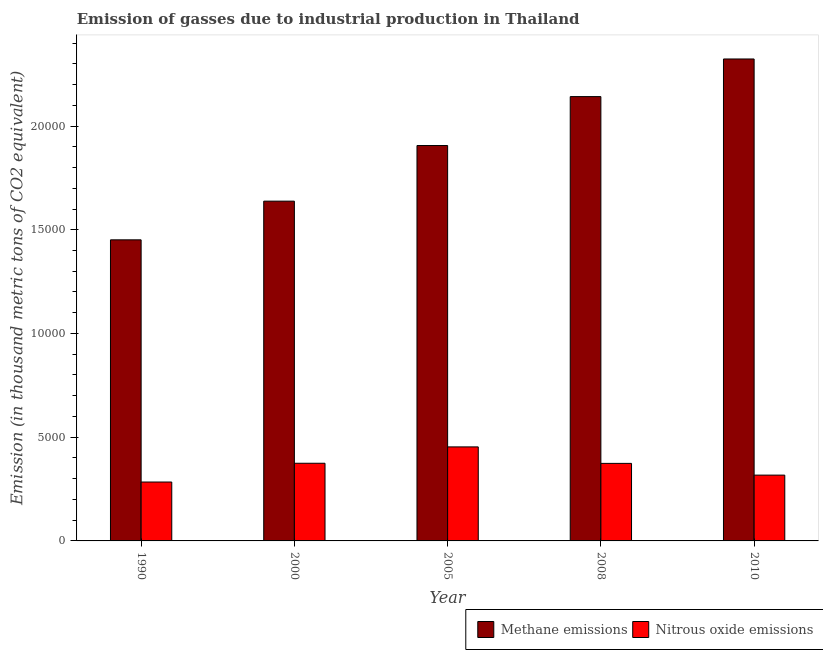How many different coloured bars are there?
Your answer should be compact. 2. How many groups of bars are there?
Your answer should be compact. 5. How many bars are there on the 4th tick from the left?
Offer a very short reply. 2. How many bars are there on the 4th tick from the right?
Offer a terse response. 2. What is the label of the 1st group of bars from the left?
Give a very brief answer. 1990. In how many cases, is the number of bars for a given year not equal to the number of legend labels?
Your answer should be very brief. 0. What is the amount of nitrous oxide emissions in 1990?
Ensure brevity in your answer.  2838.9. Across all years, what is the maximum amount of methane emissions?
Provide a short and direct response. 2.32e+04. Across all years, what is the minimum amount of nitrous oxide emissions?
Keep it short and to the point. 2838.9. In which year was the amount of nitrous oxide emissions maximum?
Your response must be concise. 2005. In which year was the amount of nitrous oxide emissions minimum?
Offer a terse response. 1990. What is the total amount of nitrous oxide emissions in the graph?
Offer a terse response. 1.80e+04. What is the difference between the amount of methane emissions in 2000 and that in 2010?
Make the answer very short. -6853.2. What is the difference between the amount of nitrous oxide emissions in 1990 and the amount of methane emissions in 2010?
Make the answer very short. -333.5. What is the average amount of methane emissions per year?
Keep it short and to the point. 1.89e+04. What is the ratio of the amount of methane emissions in 2000 to that in 2005?
Ensure brevity in your answer.  0.86. Is the amount of nitrous oxide emissions in 1990 less than that in 2005?
Your answer should be very brief. Yes. Is the difference between the amount of methane emissions in 2000 and 2010 greater than the difference between the amount of nitrous oxide emissions in 2000 and 2010?
Your answer should be very brief. No. What is the difference between the highest and the second highest amount of nitrous oxide emissions?
Provide a short and direct response. 788.7. What is the difference between the highest and the lowest amount of nitrous oxide emissions?
Your response must be concise. 1693.5. In how many years, is the amount of nitrous oxide emissions greater than the average amount of nitrous oxide emissions taken over all years?
Provide a succinct answer. 3. Is the sum of the amount of methane emissions in 2008 and 2010 greater than the maximum amount of nitrous oxide emissions across all years?
Ensure brevity in your answer.  Yes. What does the 2nd bar from the left in 2005 represents?
Keep it short and to the point. Nitrous oxide emissions. What does the 2nd bar from the right in 2008 represents?
Your response must be concise. Methane emissions. How many bars are there?
Make the answer very short. 10. Are all the bars in the graph horizontal?
Your answer should be very brief. No. How many years are there in the graph?
Offer a terse response. 5. What is the difference between two consecutive major ticks on the Y-axis?
Give a very brief answer. 5000. Does the graph contain any zero values?
Give a very brief answer. No. Where does the legend appear in the graph?
Give a very brief answer. Bottom right. How are the legend labels stacked?
Ensure brevity in your answer.  Horizontal. What is the title of the graph?
Your response must be concise. Emission of gasses due to industrial production in Thailand. What is the label or title of the Y-axis?
Give a very brief answer. Emission (in thousand metric tons of CO2 equivalent). What is the Emission (in thousand metric tons of CO2 equivalent) in Methane emissions in 1990?
Your answer should be very brief. 1.45e+04. What is the Emission (in thousand metric tons of CO2 equivalent) of Nitrous oxide emissions in 1990?
Your response must be concise. 2838.9. What is the Emission (in thousand metric tons of CO2 equivalent) of Methane emissions in 2000?
Your answer should be very brief. 1.64e+04. What is the Emission (in thousand metric tons of CO2 equivalent) of Nitrous oxide emissions in 2000?
Offer a terse response. 3743.7. What is the Emission (in thousand metric tons of CO2 equivalent) of Methane emissions in 2005?
Your answer should be very brief. 1.91e+04. What is the Emission (in thousand metric tons of CO2 equivalent) in Nitrous oxide emissions in 2005?
Ensure brevity in your answer.  4532.4. What is the Emission (in thousand metric tons of CO2 equivalent) in Methane emissions in 2008?
Your answer should be compact. 2.14e+04. What is the Emission (in thousand metric tons of CO2 equivalent) of Nitrous oxide emissions in 2008?
Make the answer very short. 3737.9. What is the Emission (in thousand metric tons of CO2 equivalent) of Methane emissions in 2010?
Your answer should be compact. 2.32e+04. What is the Emission (in thousand metric tons of CO2 equivalent) in Nitrous oxide emissions in 2010?
Your answer should be very brief. 3172.4. Across all years, what is the maximum Emission (in thousand metric tons of CO2 equivalent) in Methane emissions?
Provide a short and direct response. 2.32e+04. Across all years, what is the maximum Emission (in thousand metric tons of CO2 equivalent) in Nitrous oxide emissions?
Offer a terse response. 4532.4. Across all years, what is the minimum Emission (in thousand metric tons of CO2 equivalent) of Methane emissions?
Your answer should be very brief. 1.45e+04. Across all years, what is the minimum Emission (in thousand metric tons of CO2 equivalent) in Nitrous oxide emissions?
Your answer should be compact. 2838.9. What is the total Emission (in thousand metric tons of CO2 equivalent) of Methane emissions in the graph?
Your answer should be compact. 9.46e+04. What is the total Emission (in thousand metric tons of CO2 equivalent) of Nitrous oxide emissions in the graph?
Provide a succinct answer. 1.80e+04. What is the difference between the Emission (in thousand metric tons of CO2 equivalent) of Methane emissions in 1990 and that in 2000?
Your answer should be very brief. -1865.4. What is the difference between the Emission (in thousand metric tons of CO2 equivalent) of Nitrous oxide emissions in 1990 and that in 2000?
Provide a succinct answer. -904.8. What is the difference between the Emission (in thousand metric tons of CO2 equivalent) in Methane emissions in 1990 and that in 2005?
Give a very brief answer. -4546.4. What is the difference between the Emission (in thousand metric tons of CO2 equivalent) in Nitrous oxide emissions in 1990 and that in 2005?
Offer a terse response. -1693.5. What is the difference between the Emission (in thousand metric tons of CO2 equivalent) of Methane emissions in 1990 and that in 2008?
Make the answer very short. -6904.8. What is the difference between the Emission (in thousand metric tons of CO2 equivalent) of Nitrous oxide emissions in 1990 and that in 2008?
Give a very brief answer. -899. What is the difference between the Emission (in thousand metric tons of CO2 equivalent) in Methane emissions in 1990 and that in 2010?
Keep it short and to the point. -8718.6. What is the difference between the Emission (in thousand metric tons of CO2 equivalent) in Nitrous oxide emissions in 1990 and that in 2010?
Provide a succinct answer. -333.5. What is the difference between the Emission (in thousand metric tons of CO2 equivalent) of Methane emissions in 2000 and that in 2005?
Your response must be concise. -2681. What is the difference between the Emission (in thousand metric tons of CO2 equivalent) in Nitrous oxide emissions in 2000 and that in 2005?
Make the answer very short. -788.7. What is the difference between the Emission (in thousand metric tons of CO2 equivalent) in Methane emissions in 2000 and that in 2008?
Ensure brevity in your answer.  -5039.4. What is the difference between the Emission (in thousand metric tons of CO2 equivalent) of Nitrous oxide emissions in 2000 and that in 2008?
Your answer should be compact. 5.8. What is the difference between the Emission (in thousand metric tons of CO2 equivalent) in Methane emissions in 2000 and that in 2010?
Offer a very short reply. -6853.2. What is the difference between the Emission (in thousand metric tons of CO2 equivalent) in Nitrous oxide emissions in 2000 and that in 2010?
Make the answer very short. 571.3. What is the difference between the Emission (in thousand metric tons of CO2 equivalent) of Methane emissions in 2005 and that in 2008?
Offer a very short reply. -2358.4. What is the difference between the Emission (in thousand metric tons of CO2 equivalent) in Nitrous oxide emissions in 2005 and that in 2008?
Ensure brevity in your answer.  794.5. What is the difference between the Emission (in thousand metric tons of CO2 equivalent) in Methane emissions in 2005 and that in 2010?
Offer a terse response. -4172.2. What is the difference between the Emission (in thousand metric tons of CO2 equivalent) of Nitrous oxide emissions in 2005 and that in 2010?
Provide a succinct answer. 1360. What is the difference between the Emission (in thousand metric tons of CO2 equivalent) in Methane emissions in 2008 and that in 2010?
Your response must be concise. -1813.8. What is the difference between the Emission (in thousand metric tons of CO2 equivalent) of Nitrous oxide emissions in 2008 and that in 2010?
Your response must be concise. 565.5. What is the difference between the Emission (in thousand metric tons of CO2 equivalent) in Methane emissions in 1990 and the Emission (in thousand metric tons of CO2 equivalent) in Nitrous oxide emissions in 2000?
Keep it short and to the point. 1.08e+04. What is the difference between the Emission (in thousand metric tons of CO2 equivalent) of Methane emissions in 1990 and the Emission (in thousand metric tons of CO2 equivalent) of Nitrous oxide emissions in 2005?
Your answer should be very brief. 9981.2. What is the difference between the Emission (in thousand metric tons of CO2 equivalent) in Methane emissions in 1990 and the Emission (in thousand metric tons of CO2 equivalent) in Nitrous oxide emissions in 2008?
Provide a short and direct response. 1.08e+04. What is the difference between the Emission (in thousand metric tons of CO2 equivalent) in Methane emissions in 1990 and the Emission (in thousand metric tons of CO2 equivalent) in Nitrous oxide emissions in 2010?
Your response must be concise. 1.13e+04. What is the difference between the Emission (in thousand metric tons of CO2 equivalent) in Methane emissions in 2000 and the Emission (in thousand metric tons of CO2 equivalent) in Nitrous oxide emissions in 2005?
Your response must be concise. 1.18e+04. What is the difference between the Emission (in thousand metric tons of CO2 equivalent) in Methane emissions in 2000 and the Emission (in thousand metric tons of CO2 equivalent) in Nitrous oxide emissions in 2008?
Offer a terse response. 1.26e+04. What is the difference between the Emission (in thousand metric tons of CO2 equivalent) of Methane emissions in 2000 and the Emission (in thousand metric tons of CO2 equivalent) of Nitrous oxide emissions in 2010?
Provide a succinct answer. 1.32e+04. What is the difference between the Emission (in thousand metric tons of CO2 equivalent) of Methane emissions in 2005 and the Emission (in thousand metric tons of CO2 equivalent) of Nitrous oxide emissions in 2008?
Offer a very short reply. 1.53e+04. What is the difference between the Emission (in thousand metric tons of CO2 equivalent) of Methane emissions in 2005 and the Emission (in thousand metric tons of CO2 equivalent) of Nitrous oxide emissions in 2010?
Keep it short and to the point. 1.59e+04. What is the difference between the Emission (in thousand metric tons of CO2 equivalent) of Methane emissions in 2008 and the Emission (in thousand metric tons of CO2 equivalent) of Nitrous oxide emissions in 2010?
Keep it short and to the point. 1.82e+04. What is the average Emission (in thousand metric tons of CO2 equivalent) in Methane emissions per year?
Offer a very short reply. 1.89e+04. What is the average Emission (in thousand metric tons of CO2 equivalent) of Nitrous oxide emissions per year?
Your answer should be compact. 3605.06. In the year 1990, what is the difference between the Emission (in thousand metric tons of CO2 equivalent) of Methane emissions and Emission (in thousand metric tons of CO2 equivalent) of Nitrous oxide emissions?
Provide a succinct answer. 1.17e+04. In the year 2000, what is the difference between the Emission (in thousand metric tons of CO2 equivalent) in Methane emissions and Emission (in thousand metric tons of CO2 equivalent) in Nitrous oxide emissions?
Offer a very short reply. 1.26e+04. In the year 2005, what is the difference between the Emission (in thousand metric tons of CO2 equivalent) in Methane emissions and Emission (in thousand metric tons of CO2 equivalent) in Nitrous oxide emissions?
Your answer should be compact. 1.45e+04. In the year 2008, what is the difference between the Emission (in thousand metric tons of CO2 equivalent) of Methane emissions and Emission (in thousand metric tons of CO2 equivalent) of Nitrous oxide emissions?
Give a very brief answer. 1.77e+04. In the year 2010, what is the difference between the Emission (in thousand metric tons of CO2 equivalent) of Methane emissions and Emission (in thousand metric tons of CO2 equivalent) of Nitrous oxide emissions?
Your answer should be compact. 2.01e+04. What is the ratio of the Emission (in thousand metric tons of CO2 equivalent) in Methane emissions in 1990 to that in 2000?
Your answer should be compact. 0.89. What is the ratio of the Emission (in thousand metric tons of CO2 equivalent) of Nitrous oxide emissions in 1990 to that in 2000?
Provide a succinct answer. 0.76. What is the ratio of the Emission (in thousand metric tons of CO2 equivalent) in Methane emissions in 1990 to that in 2005?
Offer a terse response. 0.76. What is the ratio of the Emission (in thousand metric tons of CO2 equivalent) in Nitrous oxide emissions in 1990 to that in 2005?
Offer a very short reply. 0.63. What is the ratio of the Emission (in thousand metric tons of CO2 equivalent) in Methane emissions in 1990 to that in 2008?
Your answer should be compact. 0.68. What is the ratio of the Emission (in thousand metric tons of CO2 equivalent) of Nitrous oxide emissions in 1990 to that in 2008?
Provide a succinct answer. 0.76. What is the ratio of the Emission (in thousand metric tons of CO2 equivalent) of Methane emissions in 1990 to that in 2010?
Give a very brief answer. 0.62. What is the ratio of the Emission (in thousand metric tons of CO2 equivalent) of Nitrous oxide emissions in 1990 to that in 2010?
Make the answer very short. 0.89. What is the ratio of the Emission (in thousand metric tons of CO2 equivalent) in Methane emissions in 2000 to that in 2005?
Your answer should be compact. 0.86. What is the ratio of the Emission (in thousand metric tons of CO2 equivalent) of Nitrous oxide emissions in 2000 to that in 2005?
Make the answer very short. 0.83. What is the ratio of the Emission (in thousand metric tons of CO2 equivalent) in Methane emissions in 2000 to that in 2008?
Keep it short and to the point. 0.76. What is the ratio of the Emission (in thousand metric tons of CO2 equivalent) in Methane emissions in 2000 to that in 2010?
Your response must be concise. 0.7. What is the ratio of the Emission (in thousand metric tons of CO2 equivalent) in Nitrous oxide emissions in 2000 to that in 2010?
Give a very brief answer. 1.18. What is the ratio of the Emission (in thousand metric tons of CO2 equivalent) of Methane emissions in 2005 to that in 2008?
Provide a succinct answer. 0.89. What is the ratio of the Emission (in thousand metric tons of CO2 equivalent) of Nitrous oxide emissions in 2005 to that in 2008?
Give a very brief answer. 1.21. What is the ratio of the Emission (in thousand metric tons of CO2 equivalent) of Methane emissions in 2005 to that in 2010?
Keep it short and to the point. 0.82. What is the ratio of the Emission (in thousand metric tons of CO2 equivalent) of Nitrous oxide emissions in 2005 to that in 2010?
Offer a very short reply. 1.43. What is the ratio of the Emission (in thousand metric tons of CO2 equivalent) of Methane emissions in 2008 to that in 2010?
Provide a succinct answer. 0.92. What is the ratio of the Emission (in thousand metric tons of CO2 equivalent) in Nitrous oxide emissions in 2008 to that in 2010?
Give a very brief answer. 1.18. What is the difference between the highest and the second highest Emission (in thousand metric tons of CO2 equivalent) of Methane emissions?
Your answer should be compact. 1813.8. What is the difference between the highest and the second highest Emission (in thousand metric tons of CO2 equivalent) in Nitrous oxide emissions?
Offer a terse response. 788.7. What is the difference between the highest and the lowest Emission (in thousand metric tons of CO2 equivalent) in Methane emissions?
Give a very brief answer. 8718.6. What is the difference between the highest and the lowest Emission (in thousand metric tons of CO2 equivalent) in Nitrous oxide emissions?
Offer a very short reply. 1693.5. 